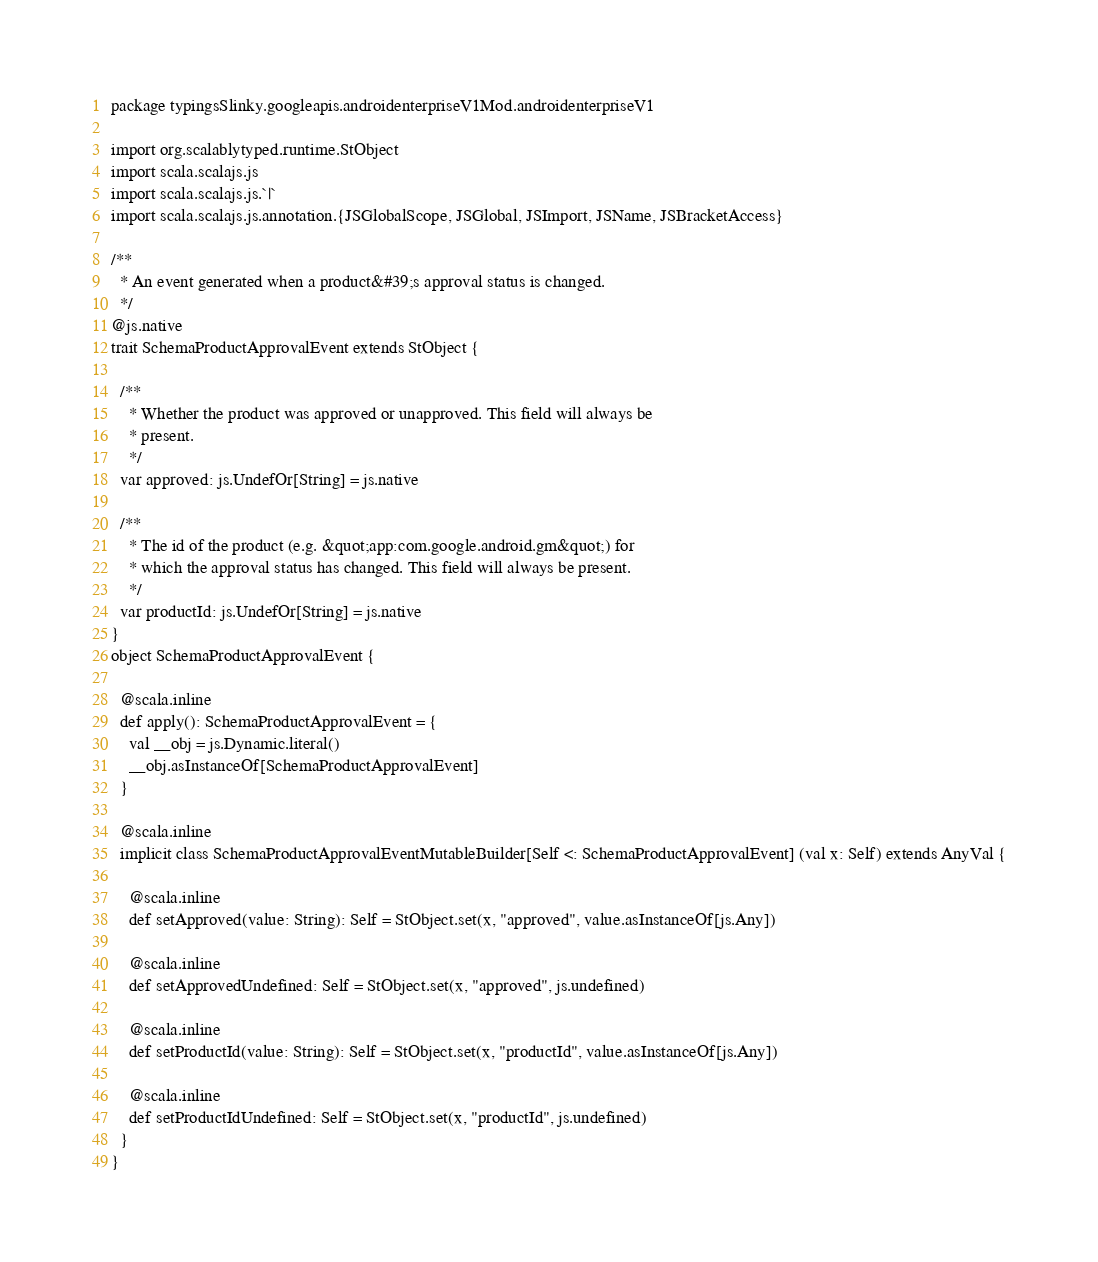<code> <loc_0><loc_0><loc_500><loc_500><_Scala_>package typingsSlinky.googleapis.androidenterpriseV1Mod.androidenterpriseV1

import org.scalablytyped.runtime.StObject
import scala.scalajs.js
import scala.scalajs.js.`|`
import scala.scalajs.js.annotation.{JSGlobalScope, JSGlobal, JSImport, JSName, JSBracketAccess}

/**
  * An event generated when a product&#39;s approval status is changed.
  */
@js.native
trait SchemaProductApprovalEvent extends StObject {
  
  /**
    * Whether the product was approved or unapproved. This field will always be
    * present.
    */
  var approved: js.UndefOr[String] = js.native
  
  /**
    * The id of the product (e.g. &quot;app:com.google.android.gm&quot;) for
    * which the approval status has changed. This field will always be present.
    */
  var productId: js.UndefOr[String] = js.native
}
object SchemaProductApprovalEvent {
  
  @scala.inline
  def apply(): SchemaProductApprovalEvent = {
    val __obj = js.Dynamic.literal()
    __obj.asInstanceOf[SchemaProductApprovalEvent]
  }
  
  @scala.inline
  implicit class SchemaProductApprovalEventMutableBuilder[Self <: SchemaProductApprovalEvent] (val x: Self) extends AnyVal {
    
    @scala.inline
    def setApproved(value: String): Self = StObject.set(x, "approved", value.asInstanceOf[js.Any])
    
    @scala.inline
    def setApprovedUndefined: Self = StObject.set(x, "approved", js.undefined)
    
    @scala.inline
    def setProductId(value: String): Self = StObject.set(x, "productId", value.asInstanceOf[js.Any])
    
    @scala.inline
    def setProductIdUndefined: Self = StObject.set(x, "productId", js.undefined)
  }
}
</code> 